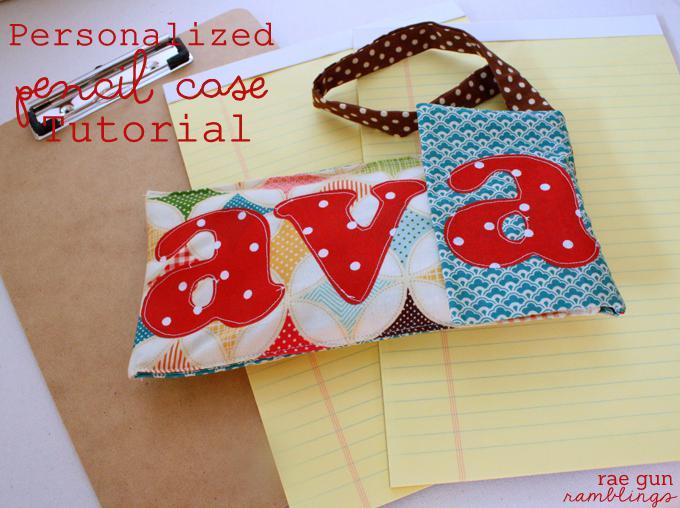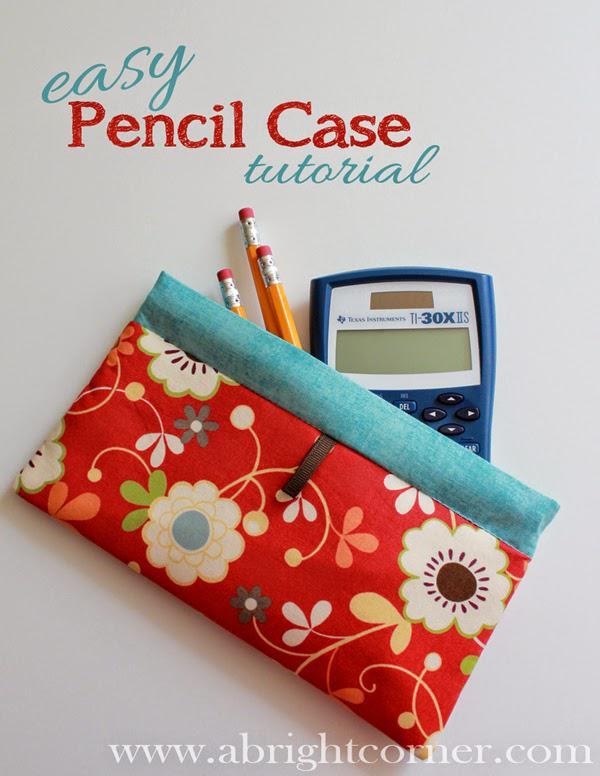The first image is the image on the left, the second image is the image on the right. Evaluate the accuracy of this statement regarding the images: "There are strawberries pictured on a total of 1 pencil case.". Is it true? Answer yes or no. No. The first image is the image on the left, the second image is the image on the right. Evaluate the accuracy of this statement regarding the images: "One image shows a pencil case lying on top of notepaper.". Is it true? Answer yes or no. Yes. 